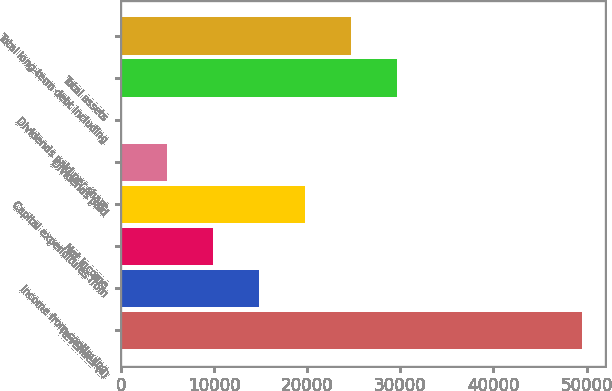Convert chart. <chart><loc_0><loc_0><loc_500><loc_500><bar_chart><fcel>Revenues (c)<fcel>Income from continuing<fcel>Net income<fcel>Capital expenditures from<fcel>Dividends paid<fcel>Dividends paid per share<fcel>Total assets<fcel>Total long-term debt including<nl><fcel>49465<fcel>14839.9<fcel>9893.41<fcel>19786.3<fcel>4946.96<fcel>0.51<fcel>29679.2<fcel>24732.8<nl></chart> 